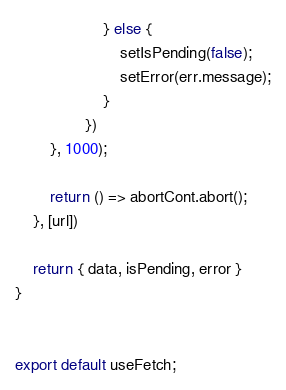<code> <loc_0><loc_0><loc_500><loc_500><_JavaScript_>                    } else {
                        setIsPending(false);
                        setError(err.message);
                    }
                })
        }, 1000);

        return () => abortCont.abort();
    }, [url])

    return { data, isPending, error }
}


export default useFetch;
</code> 